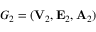<formula> <loc_0><loc_0><loc_500><loc_500>G _ { 2 } = ( { V } _ { 2 } , { E } _ { 2 } , { A } _ { 2 } )</formula> 